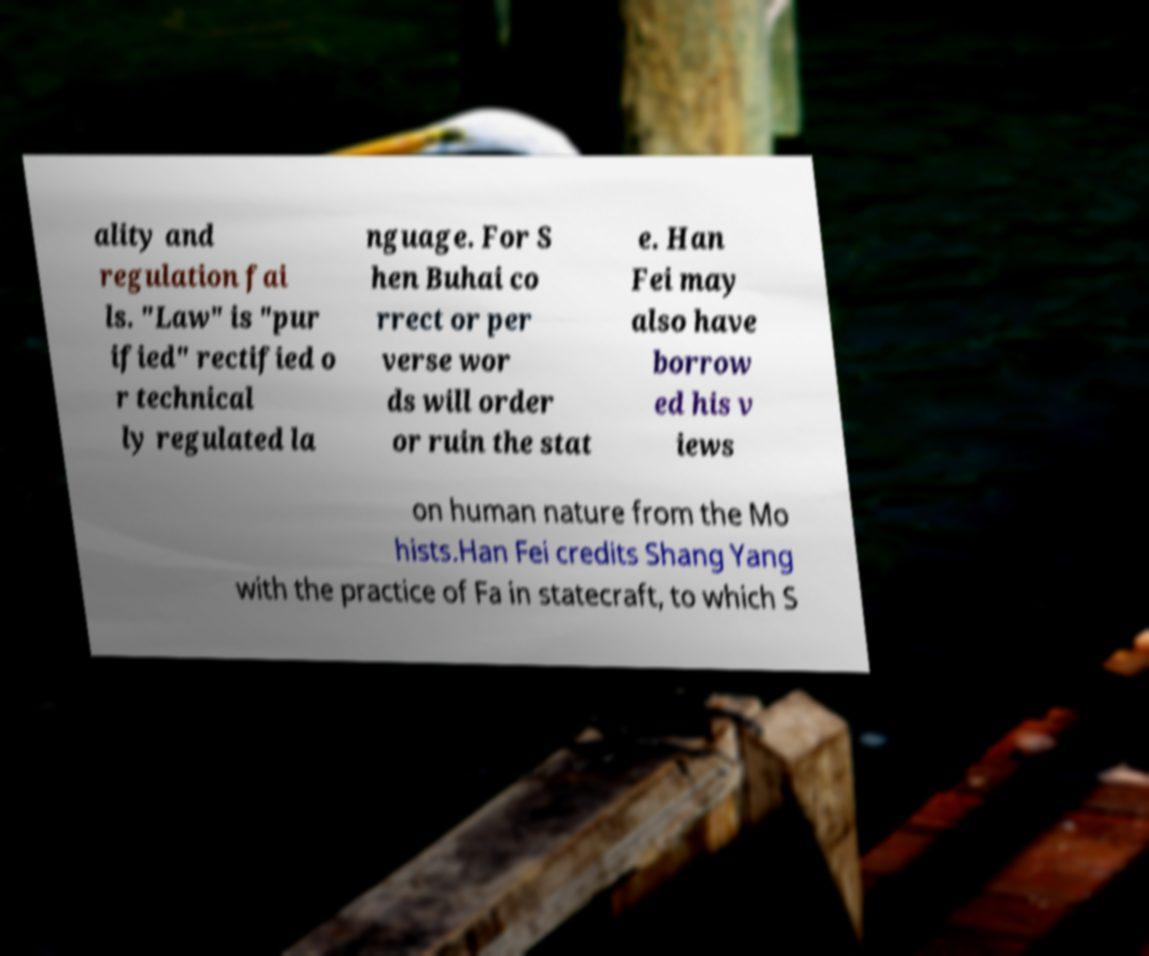For documentation purposes, I need the text within this image transcribed. Could you provide that? ality and regulation fai ls. "Law" is "pur ified" rectified o r technical ly regulated la nguage. For S hen Buhai co rrect or per verse wor ds will order or ruin the stat e. Han Fei may also have borrow ed his v iews on human nature from the Mo hists.Han Fei credits Shang Yang with the practice of Fa in statecraft, to which S 